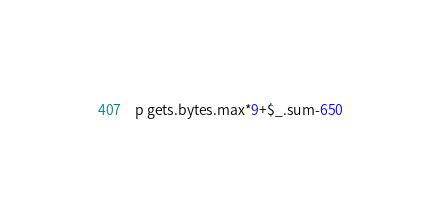<code> <loc_0><loc_0><loc_500><loc_500><_Ruby_>p gets.bytes.max*9+$_.sum-650</code> 